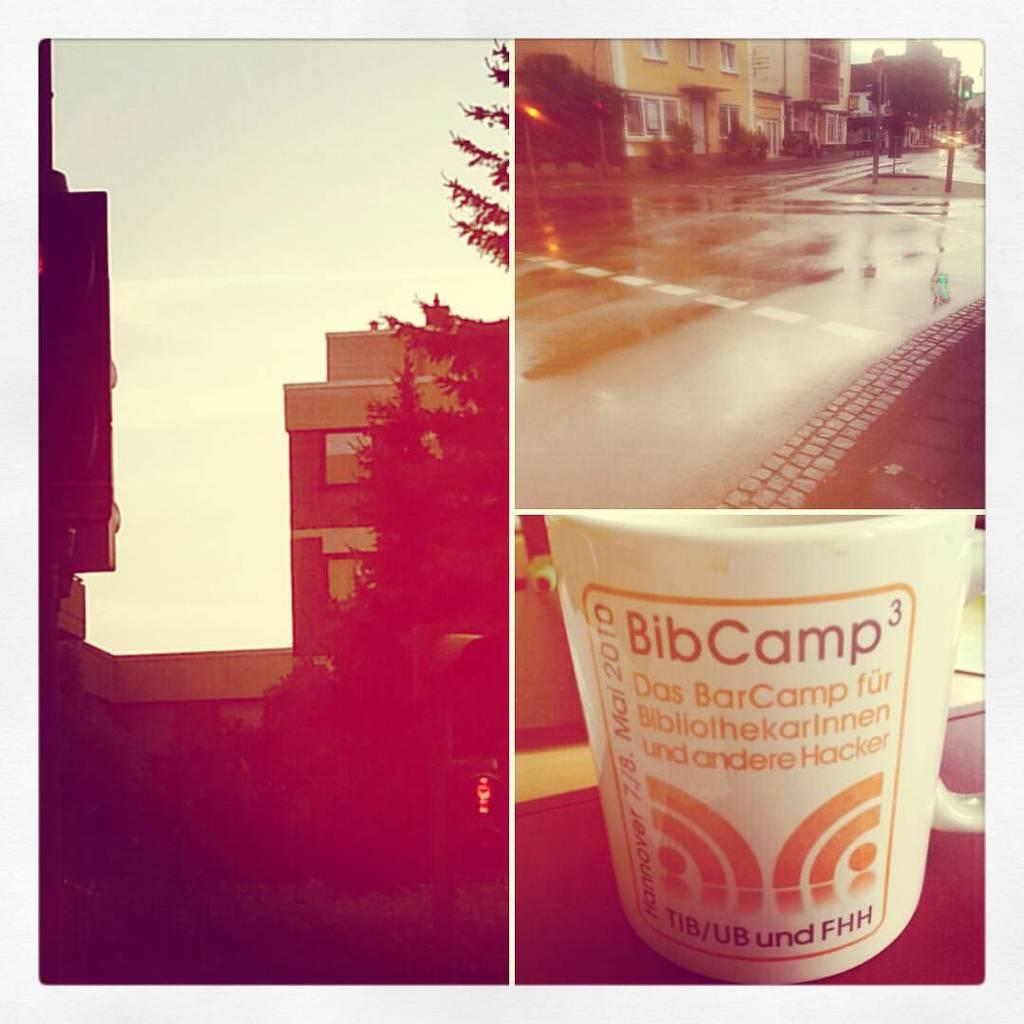<image>
Give a short and clear explanation of the subsequent image. a Bib Camp container with a design on it 